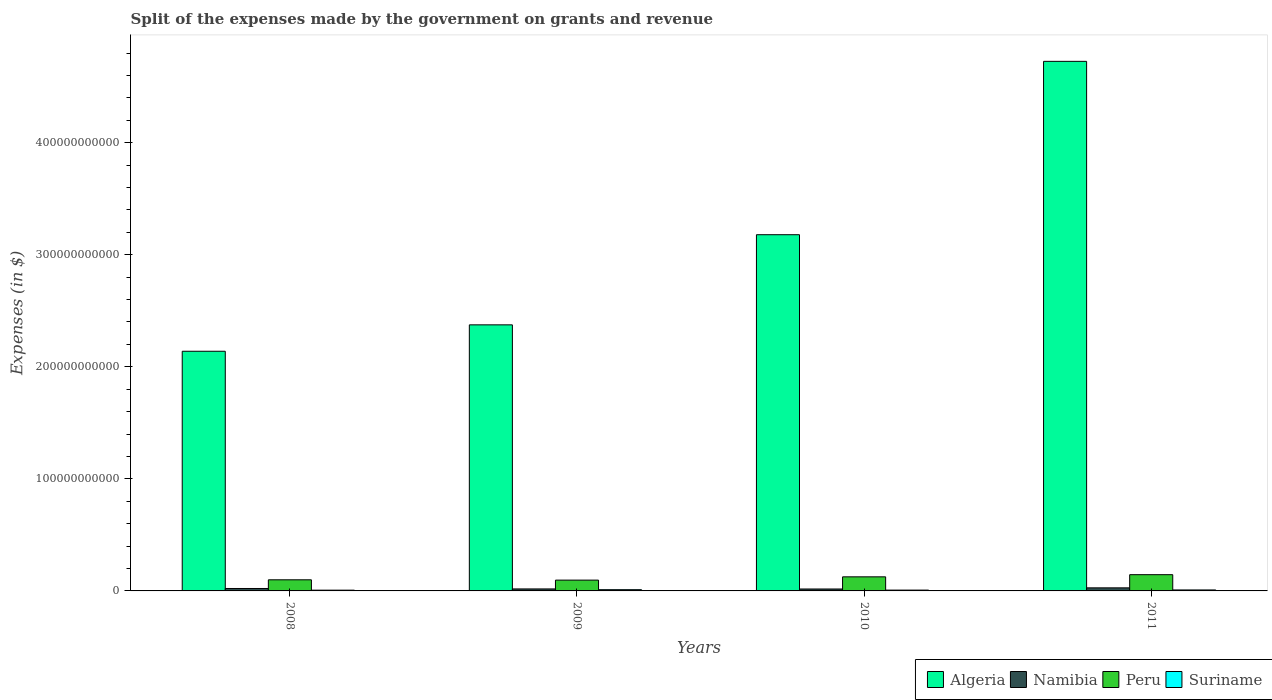How many different coloured bars are there?
Make the answer very short. 4. How many groups of bars are there?
Give a very brief answer. 4. Are the number of bars on each tick of the X-axis equal?
Provide a short and direct response. Yes. How many bars are there on the 3rd tick from the left?
Give a very brief answer. 4. What is the label of the 3rd group of bars from the left?
Make the answer very short. 2010. What is the expenses made by the government on grants and revenue in Peru in 2011?
Your answer should be compact. 1.45e+1. Across all years, what is the maximum expenses made by the government on grants and revenue in Namibia?
Make the answer very short. 2.73e+09. Across all years, what is the minimum expenses made by the government on grants and revenue in Peru?
Give a very brief answer. 9.64e+09. In which year was the expenses made by the government on grants and revenue in Algeria maximum?
Your response must be concise. 2011. In which year was the expenses made by the government on grants and revenue in Algeria minimum?
Make the answer very short. 2008. What is the total expenses made by the government on grants and revenue in Suriname in the graph?
Make the answer very short. 3.38e+09. What is the difference between the expenses made by the government on grants and revenue in Algeria in 2008 and that in 2010?
Your response must be concise. -1.04e+11. What is the difference between the expenses made by the government on grants and revenue in Suriname in 2011 and the expenses made by the government on grants and revenue in Namibia in 2008?
Provide a succinct answer. -1.30e+09. What is the average expenses made by the government on grants and revenue in Suriname per year?
Your answer should be compact. 8.46e+08. In the year 2011, what is the difference between the expenses made by the government on grants and revenue in Namibia and expenses made by the government on grants and revenue in Peru?
Provide a short and direct response. -1.18e+1. In how many years, is the expenses made by the government on grants and revenue in Suriname greater than 100000000000 $?
Your answer should be compact. 0. What is the ratio of the expenses made by the government on grants and revenue in Algeria in 2009 to that in 2010?
Offer a very short reply. 0.75. What is the difference between the highest and the second highest expenses made by the government on grants and revenue in Namibia?
Your answer should be compact. 5.59e+08. What is the difference between the highest and the lowest expenses made by the government on grants and revenue in Algeria?
Provide a short and direct response. 2.59e+11. What does the 4th bar from the left in 2008 represents?
Provide a short and direct response. Suriname. What does the 3rd bar from the right in 2011 represents?
Ensure brevity in your answer.  Namibia. Is it the case that in every year, the sum of the expenses made by the government on grants and revenue in Peru and expenses made by the government on grants and revenue in Algeria is greater than the expenses made by the government on grants and revenue in Namibia?
Offer a terse response. Yes. Are all the bars in the graph horizontal?
Keep it short and to the point. No. How many years are there in the graph?
Provide a short and direct response. 4. What is the difference between two consecutive major ticks on the Y-axis?
Make the answer very short. 1.00e+11. Does the graph contain any zero values?
Ensure brevity in your answer.  No. What is the title of the graph?
Ensure brevity in your answer.  Split of the expenses made by the government on grants and revenue. Does "Upper middle income" appear as one of the legend labels in the graph?
Provide a short and direct response. No. What is the label or title of the X-axis?
Keep it short and to the point. Years. What is the label or title of the Y-axis?
Ensure brevity in your answer.  Expenses (in $). What is the Expenses (in $) of Algeria in 2008?
Your answer should be compact. 2.14e+11. What is the Expenses (in $) of Namibia in 2008?
Provide a short and direct response. 2.17e+09. What is the Expenses (in $) in Peru in 2008?
Your answer should be very brief. 9.92e+09. What is the Expenses (in $) in Suriname in 2008?
Your answer should be compact. 6.72e+08. What is the Expenses (in $) of Algeria in 2009?
Offer a terse response. 2.37e+11. What is the Expenses (in $) in Namibia in 2009?
Keep it short and to the point. 1.77e+09. What is the Expenses (in $) of Peru in 2009?
Ensure brevity in your answer.  9.64e+09. What is the Expenses (in $) of Suriname in 2009?
Give a very brief answer. 1.11e+09. What is the Expenses (in $) in Algeria in 2010?
Make the answer very short. 3.18e+11. What is the Expenses (in $) in Namibia in 2010?
Make the answer very short. 1.72e+09. What is the Expenses (in $) of Peru in 2010?
Make the answer very short. 1.26e+1. What is the Expenses (in $) of Suriname in 2010?
Ensure brevity in your answer.  7.28e+08. What is the Expenses (in $) in Algeria in 2011?
Your response must be concise. 4.73e+11. What is the Expenses (in $) in Namibia in 2011?
Ensure brevity in your answer.  2.73e+09. What is the Expenses (in $) of Peru in 2011?
Provide a short and direct response. 1.45e+1. What is the Expenses (in $) in Suriname in 2011?
Offer a very short reply. 8.71e+08. Across all years, what is the maximum Expenses (in $) in Algeria?
Give a very brief answer. 4.73e+11. Across all years, what is the maximum Expenses (in $) in Namibia?
Provide a short and direct response. 2.73e+09. Across all years, what is the maximum Expenses (in $) of Peru?
Your response must be concise. 1.45e+1. Across all years, what is the maximum Expenses (in $) in Suriname?
Ensure brevity in your answer.  1.11e+09. Across all years, what is the minimum Expenses (in $) in Algeria?
Offer a very short reply. 2.14e+11. Across all years, what is the minimum Expenses (in $) in Namibia?
Your answer should be very brief. 1.72e+09. Across all years, what is the minimum Expenses (in $) in Peru?
Your answer should be very brief. 9.64e+09. Across all years, what is the minimum Expenses (in $) in Suriname?
Your answer should be compact. 6.72e+08. What is the total Expenses (in $) in Algeria in the graph?
Your answer should be compact. 1.24e+12. What is the total Expenses (in $) of Namibia in the graph?
Provide a succinct answer. 8.41e+09. What is the total Expenses (in $) in Peru in the graph?
Offer a terse response. 4.66e+1. What is the total Expenses (in $) in Suriname in the graph?
Provide a succinct answer. 3.38e+09. What is the difference between the Expenses (in $) of Algeria in 2008 and that in 2009?
Your answer should be compact. -2.36e+1. What is the difference between the Expenses (in $) of Namibia in 2008 and that in 2009?
Provide a short and direct response. 4.01e+08. What is the difference between the Expenses (in $) of Peru in 2008 and that in 2009?
Your answer should be very brief. 2.78e+08. What is the difference between the Expenses (in $) of Suriname in 2008 and that in 2009?
Your response must be concise. -4.41e+08. What is the difference between the Expenses (in $) of Algeria in 2008 and that in 2010?
Offer a terse response. -1.04e+11. What is the difference between the Expenses (in $) in Namibia in 2008 and that in 2010?
Ensure brevity in your answer.  4.50e+08. What is the difference between the Expenses (in $) in Peru in 2008 and that in 2010?
Keep it short and to the point. -2.64e+09. What is the difference between the Expenses (in $) of Suriname in 2008 and that in 2010?
Your response must be concise. -5.62e+07. What is the difference between the Expenses (in $) of Algeria in 2008 and that in 2011?
Give a very brief answer. -2.59e+11. What is the difference between the Expenses (in $) of Namibia in 2008 and that in 2011?
Offer a terse response. -5.59e+08. What is the difference between the Expenses (in $) in Peru in 2008 and that in 2011?
Your response must be concise. -4.58e+09. What is the difference between the Expenses (in $) of Suriname in 2008 and that in 2011?
Offer a very short reply. -1.99e+08. What is the difference between the Expenses (in $) of Algeria in 2009 and that in 2010?
Provide a short and direct response. -8.04e+1. What is the difference between the Expenses (in $) of Namibia in 2009 and that in 2010?
Ensure brevity in your answer.  4.94e+07. What is the difference between the Expenses (in $) of Peru in 2009 and that in 2010?
Offer a terse response. -2.92e+09. What is the difference between the Expenses (in $) in Suriname in 2009 and that in 2010?
Offer a very short reply. 3.84e+08. What is the difference between the Expenses (in $) in Algeria in 2009 and that in 2011?
Offer a very short reply. -2.35e+11. What is the difference between the Expenses (in $) in Namibia in 2009 and that in 2011?
Offer a terse response. -9.60e+08. What is the difference between the Expenses (in $) in Peru in 2009 and that in 2011?
Provide a succinct answer. -4.86e+09. What is the difference between the Expenses (in $) of Suriname in 2009 and that in 2011?
Give a very brief answer. 2.42e+08. What is the difference between the Expenses (in $) in Algeria in 2010 and that in 2011?
Keep it short and to the point. -1.55e+11. What is the difference between the Expenses (in $) of Namibia in 2010 and that in 2011?
Provide a short and direct response. -1.01e+09. What is the difference between the Expenses (in $) of Peru in 2010 and that in 2011?
Make the answer very short. -1.94e+09. What is the difference between the Expenses (in $) in Suriname in 2010 and that in 2011?
Give a very brief answer. -1.42e+08. What is the difference between the Expenses (in $) of Algeria in 2008 and the Expenses (in $) of Namibia in 2009?
Your response must be concise. 2.12e+11. What is the difference between the Expenses (in $) of Algeria in 2008 and the Expenses (in $) of Peru in 2009?
Make the answer very short. 2.04e+11. What is the difference between the Expenses (in $) of Algeria in 2008 and the Expenses (in $) of Suriname in 2009?
Offer a terse response. 2.13e+11. What is the difference between the Expenses (in $) of Namibia in 2008 and the Expenses (in $) of Peru in 2009?
Offer a very short reply. -7.47e+09. What is the difference between the Expenses (in $) of Namibia in 2008 and the Expenses (in $) of Suriname in 2009?
Provide a short and direct response. 1.06e+09. What is the difference between the Expenses (in $) of Peru in 2008 and the Expenses (in $) of Suriname in 2009?
Your answer should be compact. 8.81e+09. What is the difference between the Expenses (in $) in Algeria in 2008 and the Expenses (in $) in Namibia in 2010?
Keep it short and to the point. 2.12e+11. What is the difference between the Expenses (in $) of Algeria in 2008 and the Expenses (in $) of Peru in 2010?
Ensure brevity in your answer.  2.01e+11. What is the difference between the Expenses (in $) in Algeria in 2008 and the Expenses (in $) in Suriname in 2010?
Your response must be concise. 2.13e+11. What is the difference between the Expenses (in $) of Namibia in 2008 and the Expenses (in $) of Peru in 2010?
Offer a terse response. -1.04e+1. What is the difference between the Expenses (in $) of Namibia in 2008 and the Expenses (in $) of Suriname in 2010?
Provide a short and direct response. 1.45e+09. What is the difference between the Expenses (in $) in Peru in 2008 and the Expenses (in $) in Suriname in 2010?
Your response must be concise. 9.19e+09. What is the difference between the Expenses (in $) in Algeria in 2008 and the Expenses (in $) in Namibia in 2011?
Your answer should be very brief. 2.11e+11. What is the difference between the Expenses (in $) in Algeria in 2008 and the Expenses (in $) in Peru in 2011?
Give a very brief answer. 1.99e+11. What is the difference between the Expenses (in $) of Algeria in 2008 and the Expenses (in $) of Suriname in 2011?
Your answer should be compact. 2.13e+11. What is the difference between the Expenses (in $) in Namibia in 2008 and the Expenses (in $) in Peru in 2011?
Make the answer very short. -1.23e+1. What is the difference between the Expenses (in $) of Namibia in 2008 and the Expenses (in $) of Suriname in 2011?
Provide a short and direct response. 1.30e+09. What is the difference between the Expenses (in $) in Peru in 2008 and the Expenses (in $) in Suriname in 2011?
Your response must be concise. 9.05e+09. What is the difference between the Expenses (in $) of Algeria in 2009 and the Expenses (in $) of Namibia in 2010?
Your response must be concise. 2.36e+11. What is the difference between the Expenses (in $) in Algeria in 2009 and the Expenses (in $) in Peru in 2010?
Keep it short and to the point. 2.25e+11. What is the difference between the Expenses (in $) of Algeria in 2009 and the Expenses (in $) of Suriname in 2010?
Your answer should be very brief. 2.37e+11. What is the difference between the Expenses (in $) of Namibia in 2009 and the Expenses (in $) of Peru in 2010?
Offer a terse response. -1.08e+1. What is the difference between the Expenses (in $) of Namibia in 2009 and the Expenses (in $) of Suriname in 2010?
Ensure brevity in your answer.  1.05e+09. What is the difference between the Expenses (in $) in Peru in 2009 and the Expenses (in $) in Suriname in 2010?
Provide a succinct answer. 8.91e+09. What is the difference between the Expenses (in $) in Algeria in 2009 and the Expenses (in $) in Namibia in 2011?
Offer a very short reply. 2.35e+11. What is the difference between the Expenses (in $) in Algeria in 2009 and the Expenses (in $) in Peru in 2011?
Provide a succinct answer. 2.23e+11. What is the difference between the Expenses (in $) of Algeria in 2009 and the Expenses (in $) of Suriname in 2011?
Provide a short and direct response. 2.37e+11. What is the difference between the Expenses (in $) in Namibia in 2009 and the Expenses (in $) in Peru in 2011?
Make the answer very short. -1.27e+1. What is the difference between the Expenses (in $) in Namibia in 2009 and the Expenses (in $) in Suriname in 2011?
Offer a very short reply. 9.03e+08. What is the difference between the Expenses (in $) in Peru in 2009 and the Expenses (in $) in Suriname in 2011?
Offer a terse response. 8.77e+09. What is the difference between the Expenses (in $) in Algeria in 2010 and the Expenses (in $) in Namibia in 2011?
Offer a very short reply. 3.15e+11. What is the difference between the Expenses (in $) of Algeria in 2010 and the Expenses (in $) of Peru in 2011?
Offer a very short reply. 3.03e+11. What is the difference between the Expenses (in $) of Algeria in 2010 and the Expenses (in $) of Suriname in 2011?
Keep it short and to the point. 3.17e+11. What is the difference between the Expenses (in $) of Namibia in 2010 and the Expenses (in $) of Peru in 2011?
Your answer should be compact. -1.28e+1. What is the difference between the Expenses (in $) in Namibia in 2010 and the Expenses (in $) in Suriname in 2011?
Offer a terse response. 8.54e+08. What is the difference between the Expenses (in $) of Peru in 2010 and the Expenses (in $) of Suriname in 2011?
Provide a short and direct response. 1.17e+1. What is the average Expenses (in $) in Algeria per year?
Your response must be concise. 3.10e+11. What is the average Expenses (in $) in Namibia per year?
Keep it short and to the point. 2.10e+09. What is the average Expenses (in $) of Peru per year?
Offer a terse response. 1.17e+1. What is the average Expenses (in $) in Suriname per year?
Offer a very short reply. 8.46e+08. In the year 2008, what is the difference between the Expenses (in $) in Algeria and Expenses (in $) in Namibia?
Offer a very short reply. 2.12e+11. In the year 2008, what is the difference between the Expenses (in $) of Algeria and Expenses (in $) of Peru?
Offer a very short reply. 2.04e+11. In the year 2008, what is the difference between the Expenses (in $) of Algeria and Expenses (in $) of Suriname?
Keep it short and to the point. 2.13e+11. In the year 2008, what is the difference between the Expenses (in $) of Namibia and Expenses (in $) of Peru?
Provide a succinct answer. -7.75e+09. In the year 2008, what is the difference between the Expenses (in $) in Namibia and Expenses (in $) in Suriname?
Give a very brief answer. 1.50e+09. In the year 2008, what is the difference between the Expenses (in $) in Peru and Expenses (in $) in Suriname?
Your answer should be compact. 9.25e+09. In the year 2009, what is the difference between the Expenses (in $) in Algeria and Expenses (in $) in Namibia?
Keep it short and to the point. 2.36e+11. In the year 2009, what is the difference between the Expenses (in $) in Algeria and Expenses (in $) in Peru?
Give a very brief answer. 2.28e+11. In the year 2009, what is the difference between the Expenses (in $) in Algeria and Expenses (in $) in Suriname?
Offer a very short reply. 2.36e+11. In the year 2009, what is the difference between the Expenses (in $) in Namibia and Expenses (in $) in Peru?
Give a very brief answer. -7.87e+09. In the year 2009, what is the difference between the Expenses (in $) in Namibia and Expenses (in $) in Suriname?
Ensure brevity in your answer.  6.61e+08. In the year 2009, what is the difference between the Expenses (in $) of Peru and Expenses (in $) of Suriname?
Make the answer very short. 8.53e+09. In the year 2010, what is the difference between the Expenses (in $) of Algeria and Expenses (in $) of Namibia?
Ensure brevity in your answer.  3.16e+11. In the year 2010, what is the difference between the Expenses (in $) of Algeria and Expenses (in $) of Peru?
Ensure brevity in your answer.  3.05e+11. In the year 2010, what is the difference between the Expenses (in $) in Algeria and Expenses (in $) in Suriname?
Provide a short and direct response. 3.17e+11. In the year 2010, what is the difference between the Expenses (in $) of Namibia and Expenses (in $) of Peru?
Offer a very short reply. -1.08e+1. In the year 2010, what is the difference between the Expenses (in $) in Namibia and Expenses (in $) in Suriname?
Ensure brevity in your answer.  9.96e+08. In the year 2010, what is the difference between the Expenses (in $) of Peru and Expenses (in $) of Suriname?
Provide a short and direct response. 1.18e+1. In the year 2011, what is the difference between the Expenses (in $) of Algeria and Expenses (in $) of Namibia?
Offer a very short reply. 4.70e+11. In the year 2011, what is the difference between the Expenses (in $) in Algeria and Expenses (in $) in Peru?
Ensure brevity in your answer.  4.58e+11. In the year 2011, what is the difference between the Expenses (in $) of Algeria and Expenses (in $) of Suriname?
Your answer should be very brief. 4.72e+11. In the year 2011, what is the difference between the Expenses (in $) in Namibia and Expenses (in $) in Peru?
Keep it short and to the point. -1.18e+1. In the year 2011, what is the difference between the Expenses (in $) in Namibia and Expenses (in $) in Suriname?
Offer a terse response. 1.86e+09. In the year 2011, what is the difference between the Expenses (in $) of Peru and Expenses (in $) of Suriname?
Make the answer very short. 1.36e+1. What is the ratio of the Expenses (in $) of Algeria in 2008 to that in 2009?
Offer a terse response. 0.9. What is the ratio of the Expenses (in $) in Namibia in 2008 to that in 2009?
Offer a terse response. 1.23. What is the ratio of the Expenses (in $) in Peru in 2008 to that in 2009?
Provide a succinct answer. 1.03. What is the ratio of the Expenses (in $) in Suriname in 2008 to that in 2009?
Give a very brief answer. 0.6. What is the ratio of the Expenses (in $) in Algeria in 2008 to that in 2010?
Give a very brief answer. 0.67. What is the ratio of the Expenses (in $) in Namibia in 2008 to that in 2010?
Offer a terse response. 1.26. What is the ratio of the Expenses (in $) of Peru in 2008 to that in 2010?
Give a very brief answer. 0.79. What is the ratio of the Expenses (in $) in Suriname in 2008 to that in 2010?
Ensure brevity in your answer.  0.92. What is the ratio of the Expenses (in $) of Algeria in 2008 to that in 2011?
Offer a terse response. 0.45. What is the ratio of the Expenses (in $) in Namibia in 2008 to that in 2011?
Make the answer very short. 0.8. What is the ratio of the Expenses (in $) in Peru in 2008 to that in 2011?
Give a very brief answer. 0.68. What is the ratio of the Expenses (in $) in Suriname in 2008 to that in 2011?
Your answer should be very brief. 0.77. What is the ratio of the Expenses (in $) in Algeria in 2009 to that in 2010?
Ensure brevity in your answer.  0.75. What is the ratio of the Expenses (in $) in Namibia in 2009 to that in 2010?
Your answer should be compact. 1.03. What is the ratio of the Expenses (in $) in Peru in 2009 to that in 2010?
Your response must be concise. 0.77. What is the ratio of the Expenses (in $) in Suriname in 2009 to that in 2010?
Your answer should be very brief. 1.53. What is the ratio of the Expenses (in $) in Algeria in 2009 to that in 2011?
Offer a terse response. 0.5. What is the ratio of the Expenses (in $) of Namibia in 2009 to that in 2011?
Provide a short and direct response. 0.65. What is the ratio of the Expenses (in $) in Peru in 2009 to that in 2011?
Ensure brevity in your answer.  0.67. What is the ratio of the Expenses (in $) of Suriname in 2009 to that in 2011?
Offer a terse response. 1.28. What is the ratio of the Expenses (in $) of Algeria in 2010 to that in 2011?
Make the answer very short. 0.67. What is the ratio of the Expenses (in $) of Namibia in 2010 to that in 2011?
Provide a short and direct response. 0.63. What is the ratio of the Expenses (in $) of Peru in 2010 to that in 2011?
Your response must be concise. 0.87. What is the ratio of the Expenses (in $) of Suriname in 2010 to that in 2011?
Offer a terse response. 0.84. What is the difference between the highest and the second highest Expenses (in $) of Algeria?
Your response must be concise. 1.55e+11. What is the difference between the highest and the second highest Expenses (in $) in Namibia?
Provide a short and direct response. 5.59e+08. What is the difference between the highest and the second highest Expenses (in $) in Peru?
Your response must be concise. 1.94e+09. What is the difference between the highest and the second highest Expenses (in $) of Suriname?
Provide a short and direct response. 2.42e+08. What is the difference between the highest and the lowest Expenses (in $) of Algeria?
Your response must be concise. 2.59e+11. What is the difference between the highest and the lowest Expenses (in $) of Namibia?
Give a very brief answer. 1.01e+09. What is the difference between the highest and the lowest Expenses (in $) of Peru?
Offer a terse response. 4.86e+09. What is the difference between the highest and the lowest Expenses (in $) in Suriname?
Your answer should be very brief. 4.41e+08. 